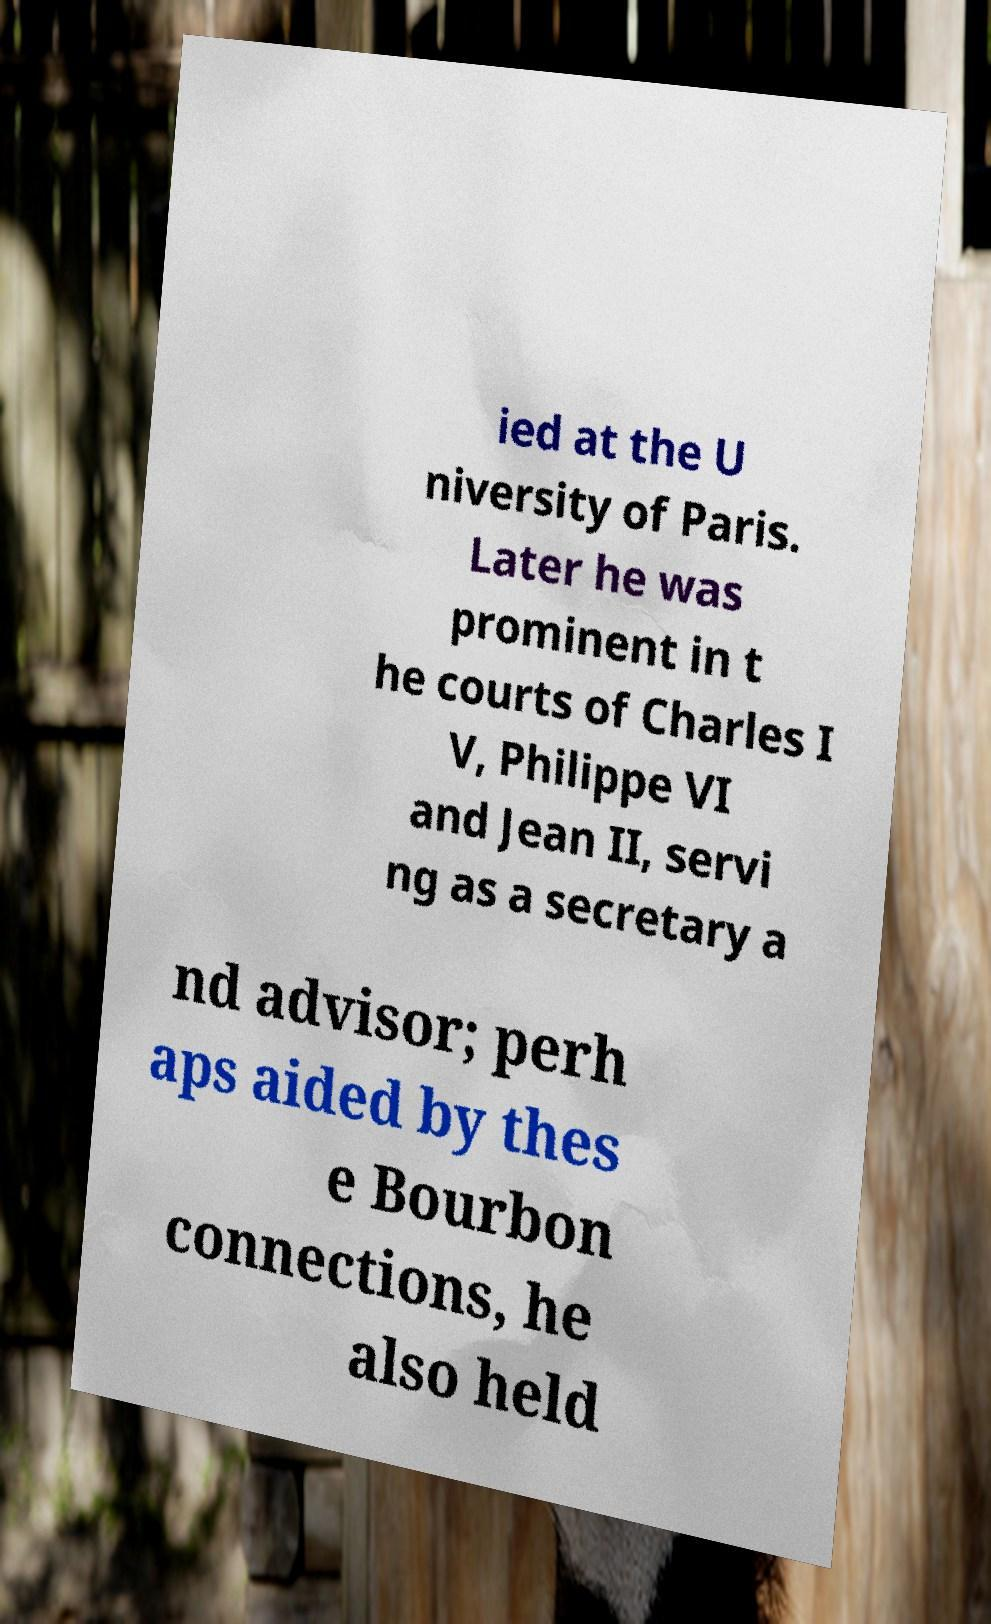Please identify and transcribe the text found in this image. ied at the U niversity of Paris. Later he was prominent in t he courts of Charles I V, Philippe VI and Jean II, servi ng as a secretary a nd advisor; perh aps aided by thes e Bourbon connections, he also held 